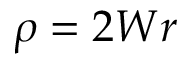Convert formula to latex. <formula><loc_0><loc_0><loc_500><loc_500>\rho = 2 W r</formula> 